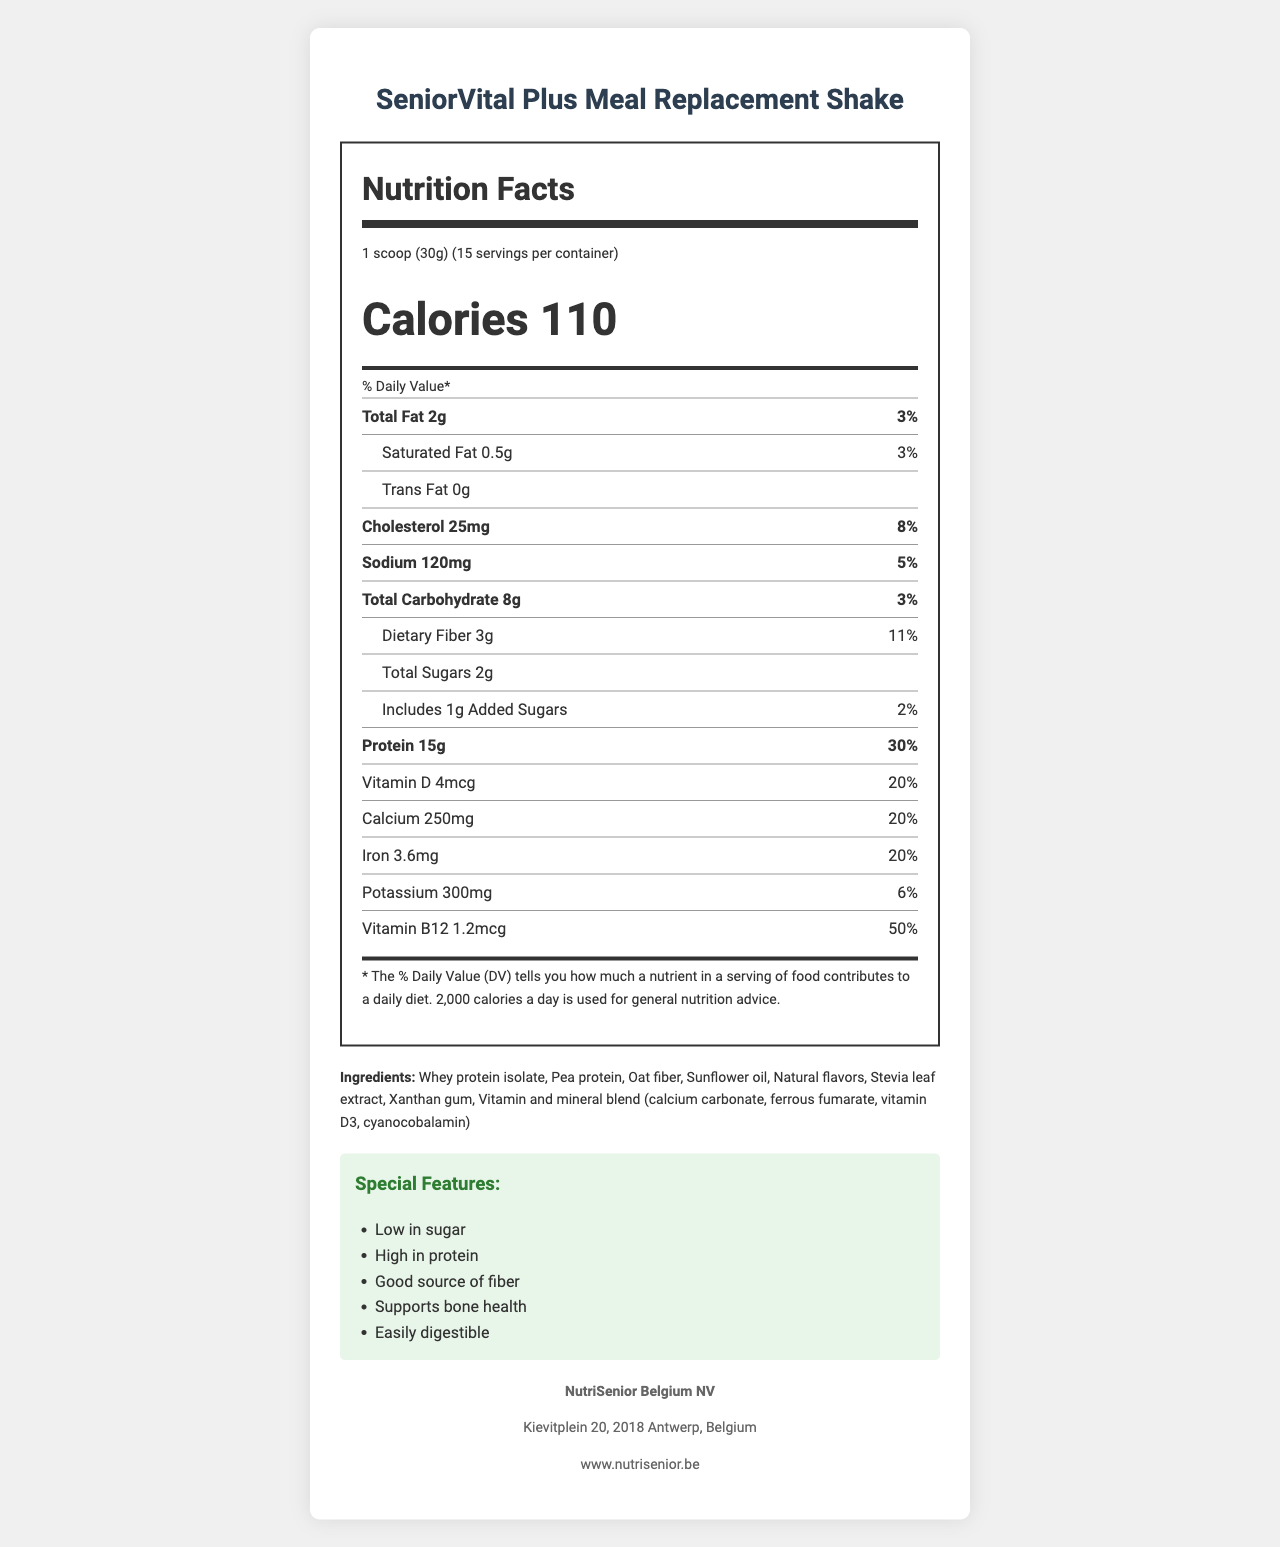what is the name of the meal replacement shake? The name of the product is clearly labeled at the top of the document.
Answer: SeniorVital Plus Meal Replacement Shake how many calories are there per serving? The calories per serving are prominently displayed in the nutrition label section.
Answer: 110 what is the serving size? The serving size is listed under the nutrition facts heading.
Answer: 1 scoop (30g) how much protein is in each serving? The protein content per serving is listed in the nutrition facts, along with a daily value percentage.
Answer: 15g how much total sugar does the product contain? The total sugars content per serving is mentioned in the nutrition facts section.
Answer: 2g What is the total fat content per serving? A. 0g B. 2g C. 5g D. 10g Total fat content per serving is 2g, as mentioned in the nutrition label.
Answer: B How many servings are in each container? I. 10 II. 15 III. 20 IV. 30 There are 15 servings per container as mentioned directly below the serving size.
Answer: II Does the product contain any allergens? The document mentions that the product contains milk and is produced in a facility that processes soy, tree nuts, and eggs.
Answer: Yes Can this product be mixed with milk? The preparation instructions state that it can be mixed with cold water or milk.
Answer: Yes Summarize the special features of this product. These features are listed in the "Special Features" section of the document, highlighting its benefits.
Answer: The product is low in sugar, high in protein, a good source of fiber, supports bone health, and is easily digestible. what is the main goal of the safety note? The safety note provides storage instructions and advises consulting a healthcare provider.
Answer: To advise storing in a cool, dry place and to consult a healthcare provider before use if there are medical conditions or medications involved where is the manufacturer located? The manufacturer's address is listed in the manufacturer info section.
Answer: Kievitplein 20, 2018 Antwerp, Belgium How much daily value of dietary fiber does one serving provide? The dietary fiber daily value percentage is provided in the nutrition label.
Answer: 11% Is there information about whether the product packaging is eco-friendly? The sustainability info states that the packaging is made from 30% recycled materials and advises recycling after use.
Answer: Yes What is the amount of added sugars in one serving? The nutrition facts state that there is 1g of added sugars per serving.
Answer: 1g What is the potassium content per serving? The potassium content per serving is listed in the nutrition label section.
Answer: 300mg What is the website of the manufacturer? The manufacturer's website is provided in the manufacturer info section.
Answer: www.nutrisenior.be How much vitamin B12 is in each serving? The vitamin B12 content per serving is listed in the nutrition label.
Answer: 1.2mcg What is the protein source in this product? The ingredients section lists whey protein isolate and pea protein as the protein sources.
Answer: Whey protein isolate, Pea protein what is the daily value percentage for calcium content? The daily value percentage for calcium is listed in the nutrition label.
Answer: 20% How should the product be stored? The safety note advises storing the product in a cool, dry place.
Answer: In a cool, dry place How many preparation options are listed for this product? The preparation instructions mention mixing with either 250ml of cold water or milk.
Answer: Two Is the product described as grip-friendly? The senior-friendly features mention that the packaging has a grip-friendly container design.
Answer: Yes what is the company's email address? The document does not provide an email address for the company.
Answer: I don't know 